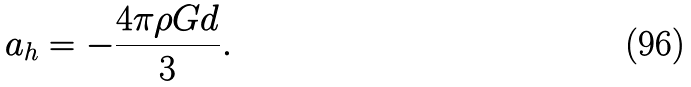<formula> <loc_0><loc_0><loc_500><loc_500>a _ { h } = - \frac { 4 \pi \rho G d } { 3 } .</formula> 